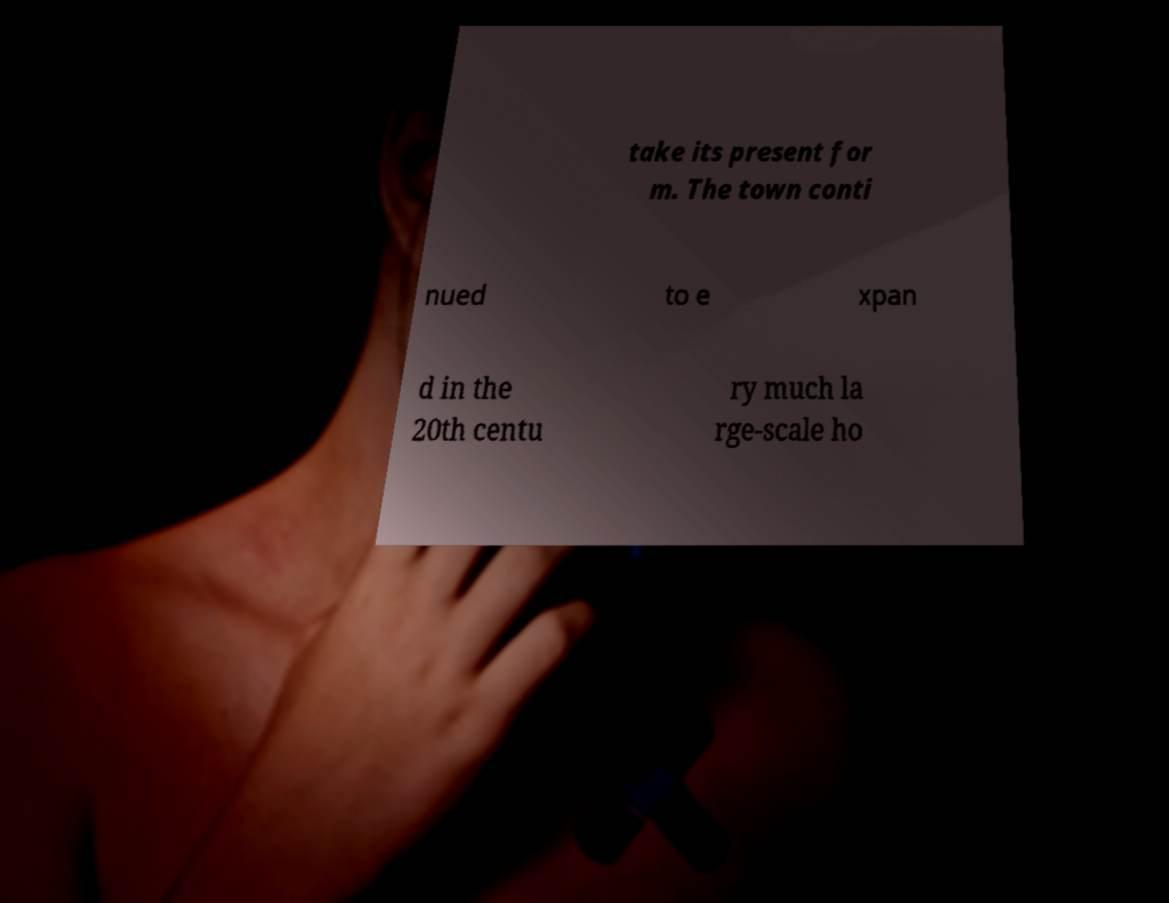Can you accurately transcribe the text from the provided image for me? take its present for m. The town conti nued to e xpan d in the 20th centu ry much la rge-scale ho 